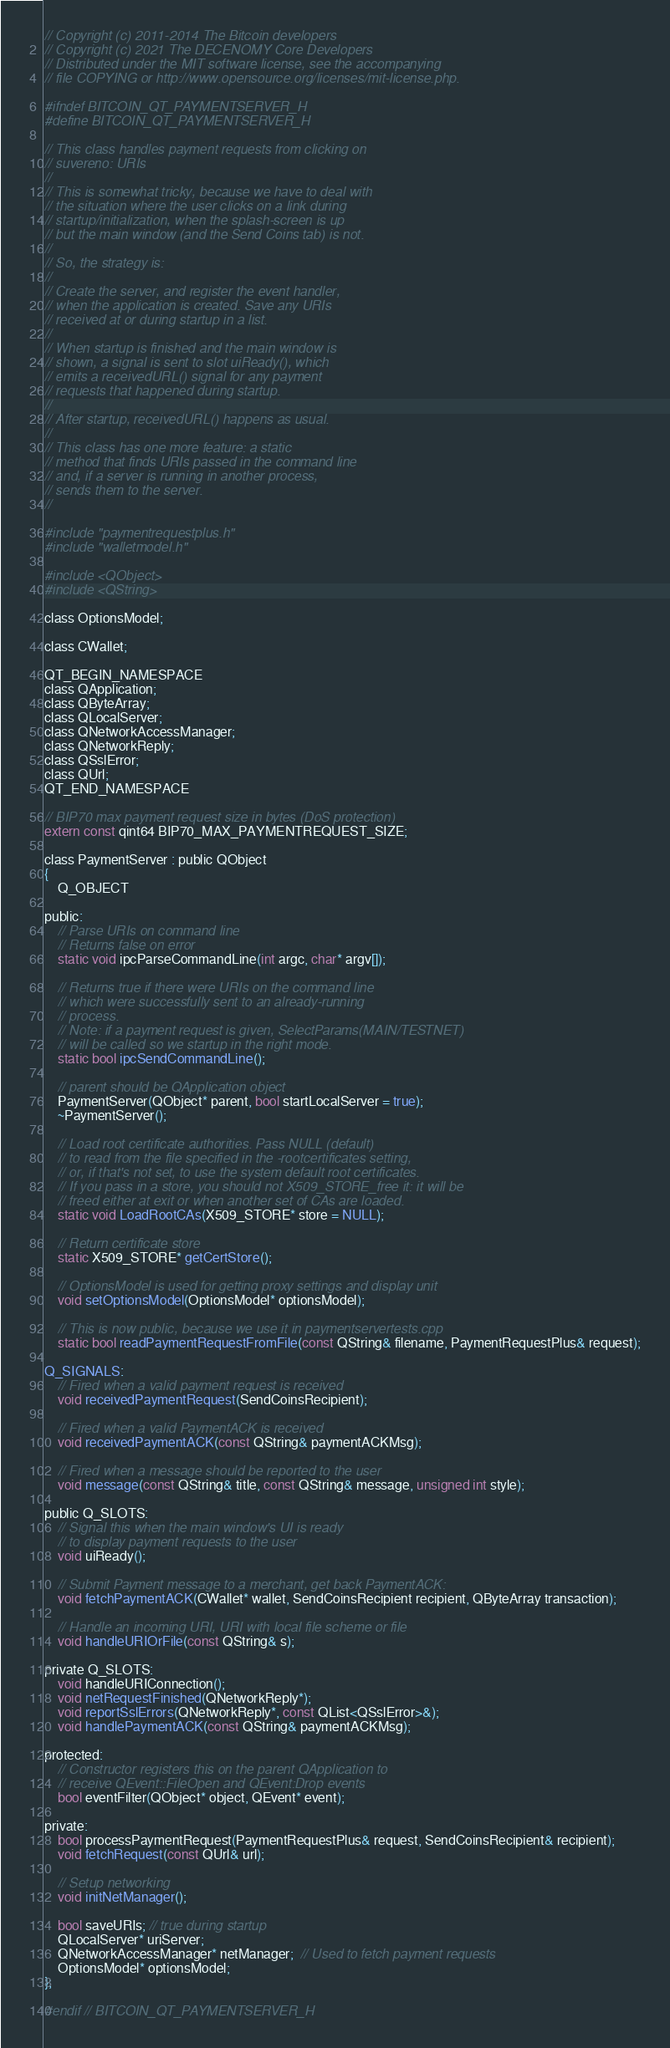Convert code to text. <code><loc_0><loc_0><loc_500><loc_500><_C_>// Copyright (c) 2011-2014 The Bitcoin developers
// Copyright (c) 2021 The DECENOMY Core Developers
// Distributed under the MIT software license, see the accompanying
// file COPYING or http://www.opensource.org/licenses/mit-license.php.

#ifndef BITCOIN_QT_PAYMENTSERVER_H
#define BITCOIN_QT_PAYMENTSERVER_H

// This class handles payment requests from clicking on
// suvereno: URIs
//
// This is somewhat tricky, because we have to deal with
// the situation where the user clicks on a link during
// startup/initialization, when the splash-screen is up
// but the main window (and the Send Coins tab) is not.
//
// So, the strategy is:
//
// Create the server, and register the event handler,
// when the application is created. Save any URIs
// received at or during startup in a list.
//
// When startup is finished and the main window is
// shown, a signal is sent to slot uiReady(), which
// emits a receivedURL() signal for any payment
// requests that happened during startup.
//
// After startup, receivedURL() happens as usual.
//
// This class has one more feature: a static
// method that finds URIs passed in the command line
// and, if a server is running in another process,
// sends them to the server.
//

#include "paymentrequestplus.h"
#include "walletmodel.h"

#include <QObject>
#include <QString>

class OptionsModel;

class CWallet;

QT_BEGIN_NAMESPACE
class QApplication;
class QByteArray;
class QLocalServer;
class QNetworkAccessManager;
class QNetworkReply;
class QSslError;
class QUrl;
QT_END_NAMESPACE

// BIP70 max payment request size in bytes (DoS protection)
extern const qint64 BIP70_MAX_PAYMENTREQUEST_SIZE;

class PaymentServer : public QObject
{
    Q_OBJECT

public:
    // Parse URIs on command line
    // Returns false on error
    static void ipcParseCommandLine(int argc, char* argv[]);

    // Returns true if there were URIs on the command line
    // which were successfully sent to an already-running
    // process.
    // Note: if a payment request is given, SelectParams(MAIN/TESTNET)
    // will be called so we startup in the right mode.
    static bool ipcSendCommandLine();

    // parent should be QApplication object
    PaymentServer(QObject* parent, bool startLocalServer = true);
    ~PaymentServer();

    // Load root certificate authorities. Pass NULL (default)
    // to read from the file specified in the -rootcertificates setting,
    // or, if that's not set, to use the system default root certificates.
    // If you pass in a store, you should not X509_STORE_free it: it will be
    // freed either at exit or when another set of CAs are loaded.
    static void LoadRootCAs(X509_STORE* store = NULL);

    // Return certificate store
    static X509_STORE* getCertStore();

    // OptionsModel is used for getting proxy settings and display unit
    void setOptionsModel(OptionsModel* optionsModel);

    // This is now public, because we use it in paymentservertests.cpp
    static bool readPaymentRequestFromFile(const QString& filename, PaymentRequestPlus& request);

Q_SIGNALS:
    // Fired when a valid payment request is received
    void receivedPaymentRequest(SendCoinsRecipient);

    // Fired when a valid PaymentACK is received
    void receivedPaymentACK(const QString& paymentACKMsg);

    // Fired when a message should be reported to the user
    void message(const QString& title, const QString& message, unsigned int style);

public Q_SLOTS:
    // Signal this when the main window's UI is ready
    // to display payment requests to the user
    void uiReady();

    // Submit Payment message to a merchant, get back PaymentACK:
    void fetchPaymentACK(CWallet* wallet, SendCoinsRecipient recipient, QByteArray transaction);

    // Handle an incoming URI, URI with local file scheme or file
    void handleURIOrFile(const QString& s);

private Q_SLOTS:
    void handleURIConnection();
    void netRequestFinished(QNetworkReply*);
    void reportSslErrors(QNetworkReply*, const QList<QSslError>&);
    void handlePaymentACK(const QString& paymentACKMsg);

protected:
    // Constructor registers this on the parent QApplication to
    // receive QEvent::FileOpen and QEvent:Drop events
    bool eventFilter(QObject* object, QEvent* event);

private:
    bool processPaymentRequest(PaymentRequestPlus& request, SendCoinsRecipient& recipient);
    void fetchRequest(const QUrl& url);

    // Setup networking
    void initNetManager();

    bool saveURIs; // true during startup
    QLocalServer* uriServer;
    QNetworkAccessManager* netManager;  // Used to fetch payment requests
    OptionsModel* optionsModel;
};

#endif // BITCOIN_QT_PAYMENTSERVER_H
</code> 